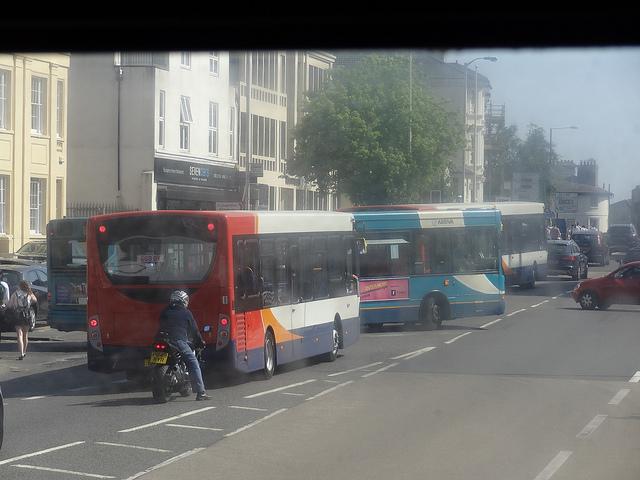How many buses are there?
Concise answer only. 3. Are there leaves on the trees?
Give a very brief answer. Yes. What is the man with the silver helmet riding?
Be succinct. Motorcycle. 